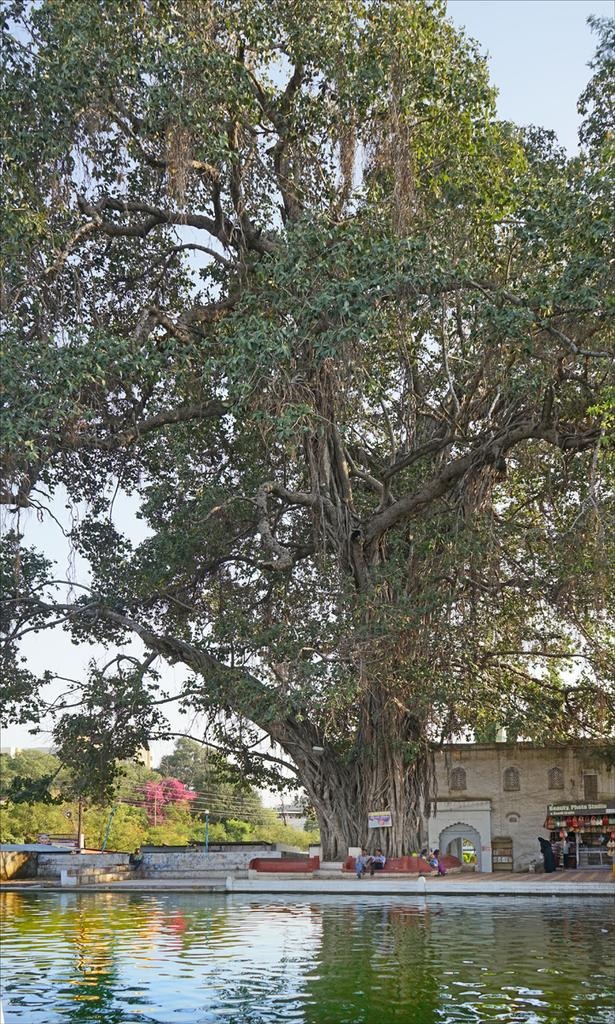What can be seen in the image? Water is visible in the image. What is present in the background of the image? There are people, at least one building, a wall, trees, and the sky visible in the background of the image. What type of attraction is being taught in the image? There is no attraction or teaching present in the image; it primarily features water and background elements. 